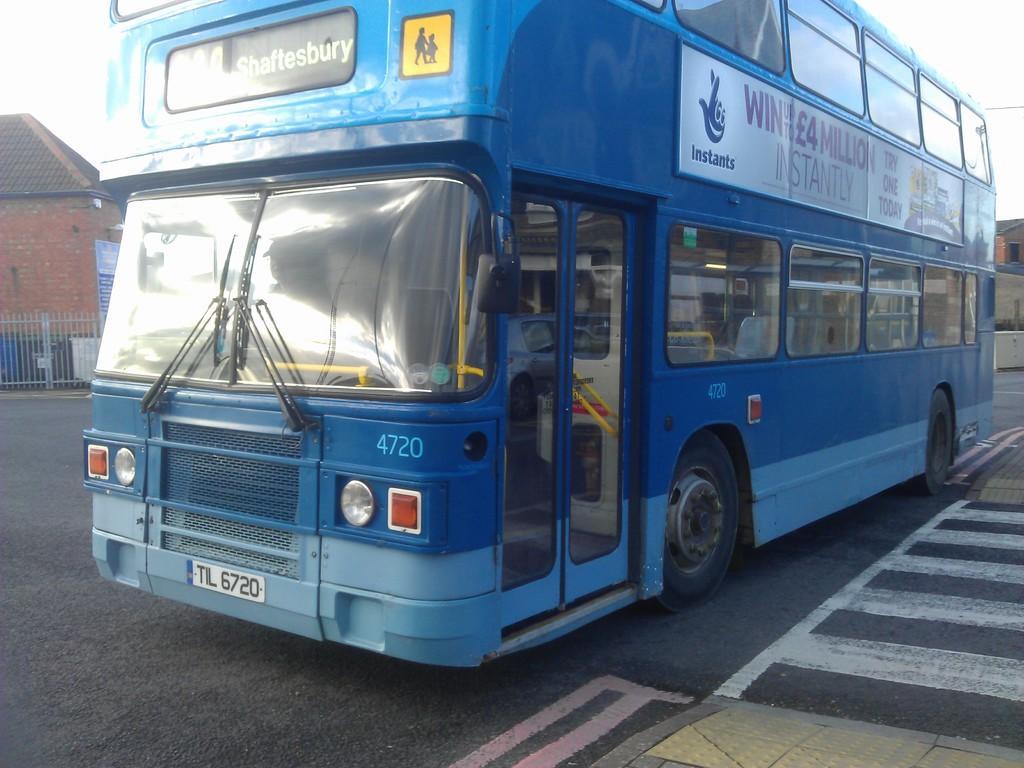Could you give a brief overview of what you see in this image? In this image I can see a blue color bus is on the road, on the left side there is the brick wall. 